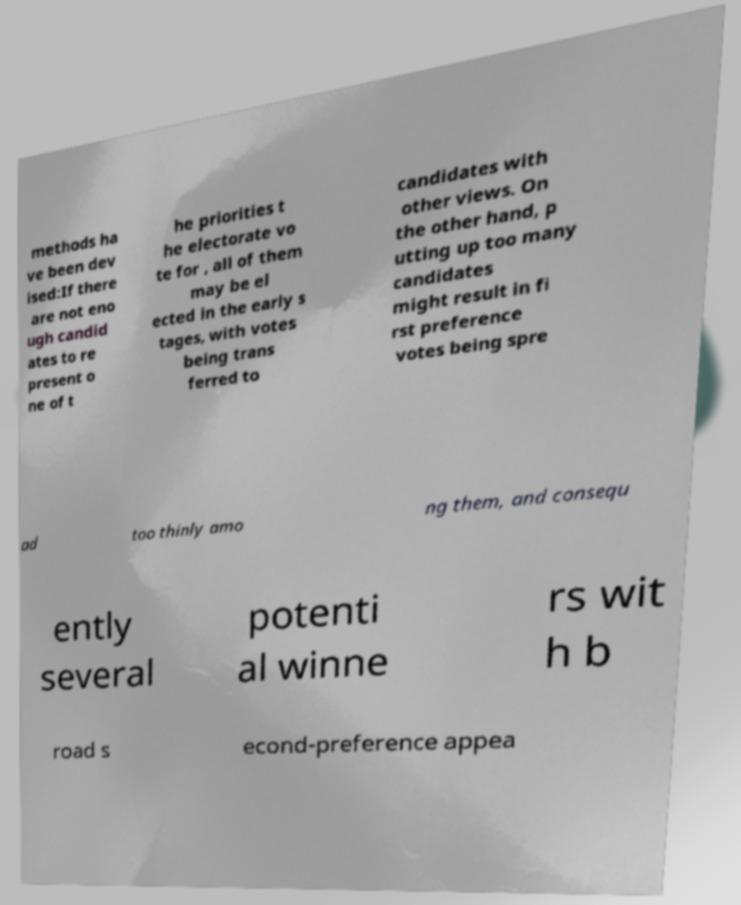Can you read and provide the text displayed in the image?This photo seems to have some interesting text. Can you extract and type it out for me? methods ha ve been dev ised:If there are not eno ugh candid ates to re present o ne of t he priorities t he electorate vo te for , all of them may be el ected in the early s tages, with votes being trans ferred to candidates with other views. On the other hand, p utting up too many candidates might result in fi rst preference votes being spre ad too thinly amo ng them, and consequ ently several potenti al winne rs wit h b road s econd-preference appea 